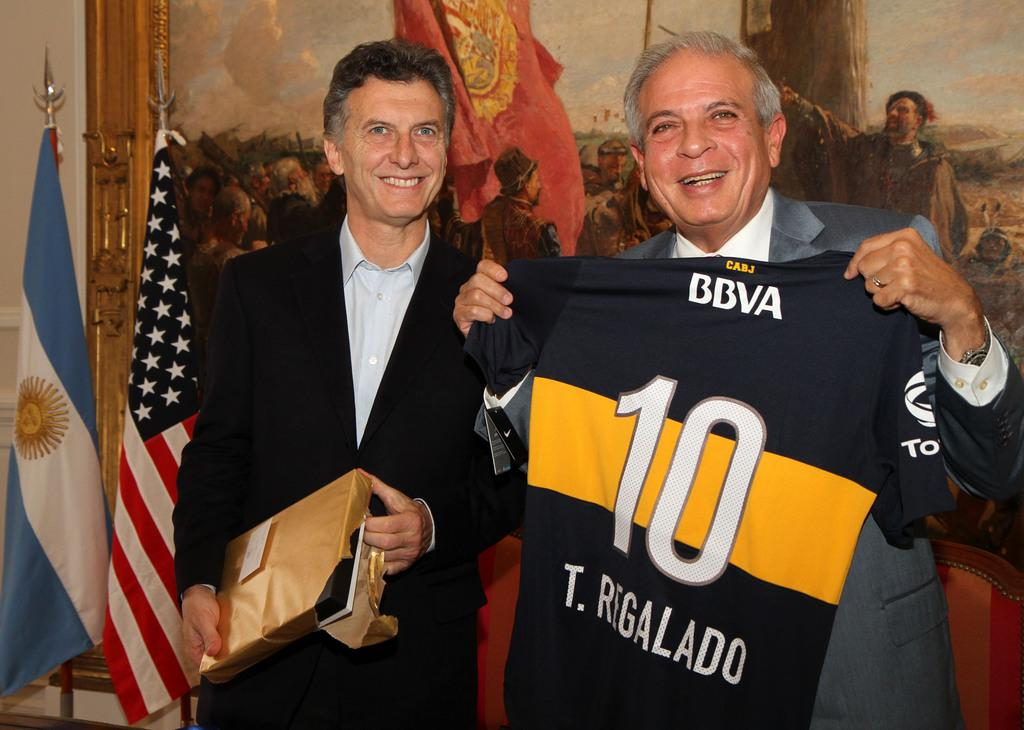<image>
Present a compact description of the photo's key features. One of the two men is holding a jersey that has the number 10 on it and the name T. Regalado. 